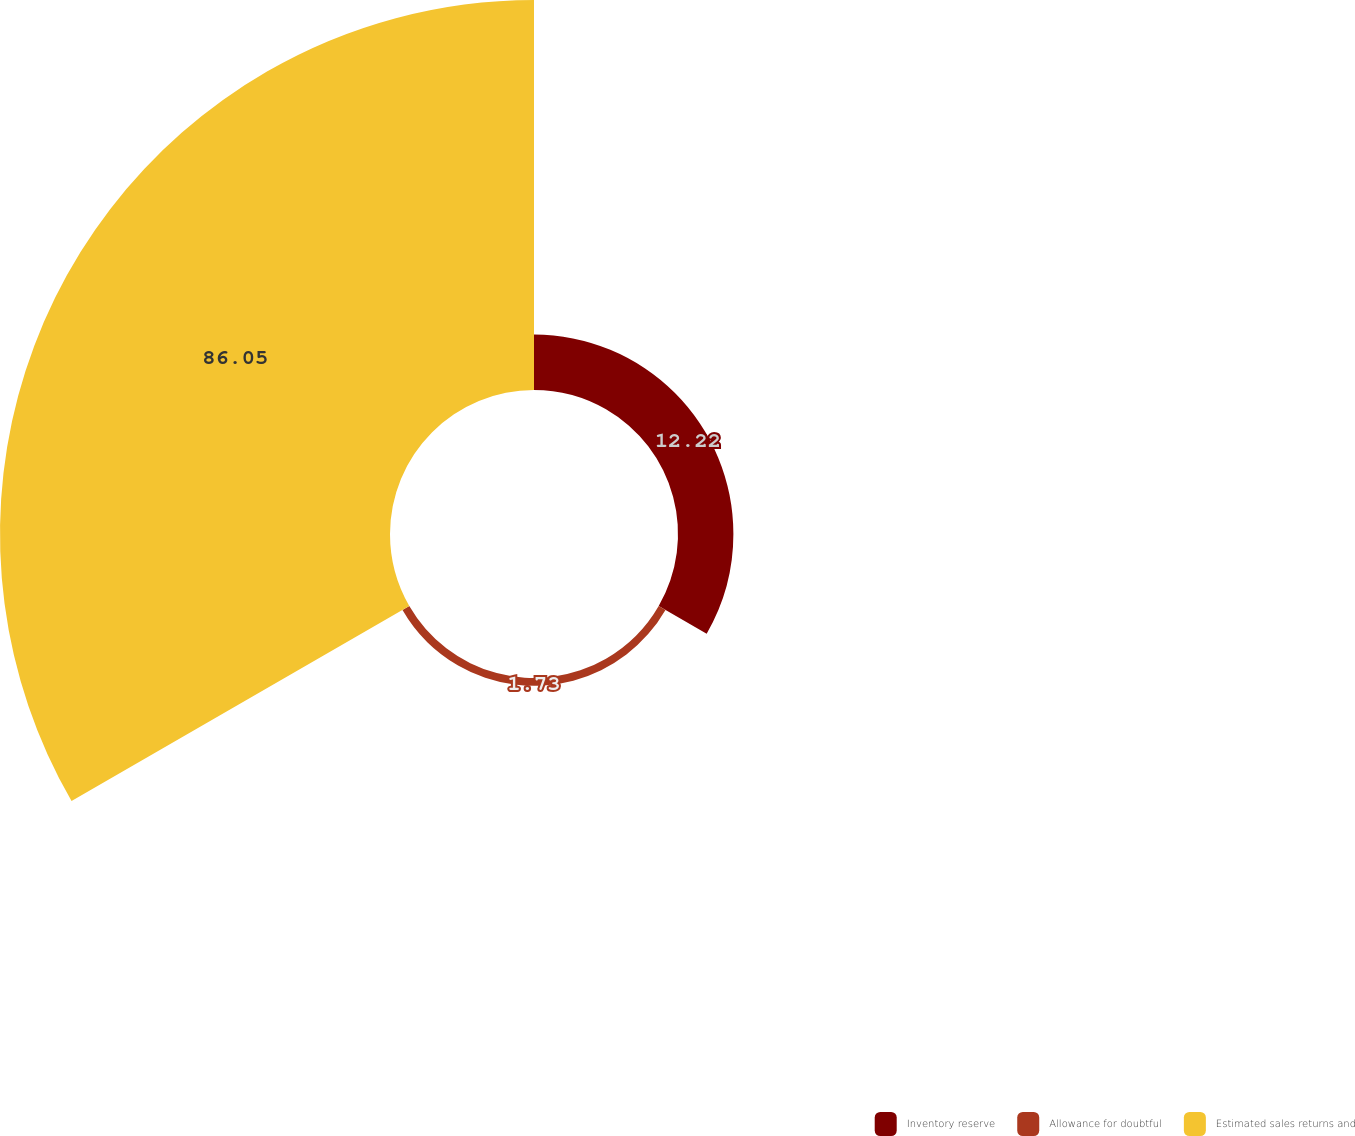<chart> <loc_0><loc_0><loc_500><loc_500><pie_chart><fcel>Inventory reserve<fcel>Allowance for doubtful<fcel>Estimated sales returns and<nl><fcel>12.22%<fcel>1.73%<fcel>86.05%<nl></chart> 